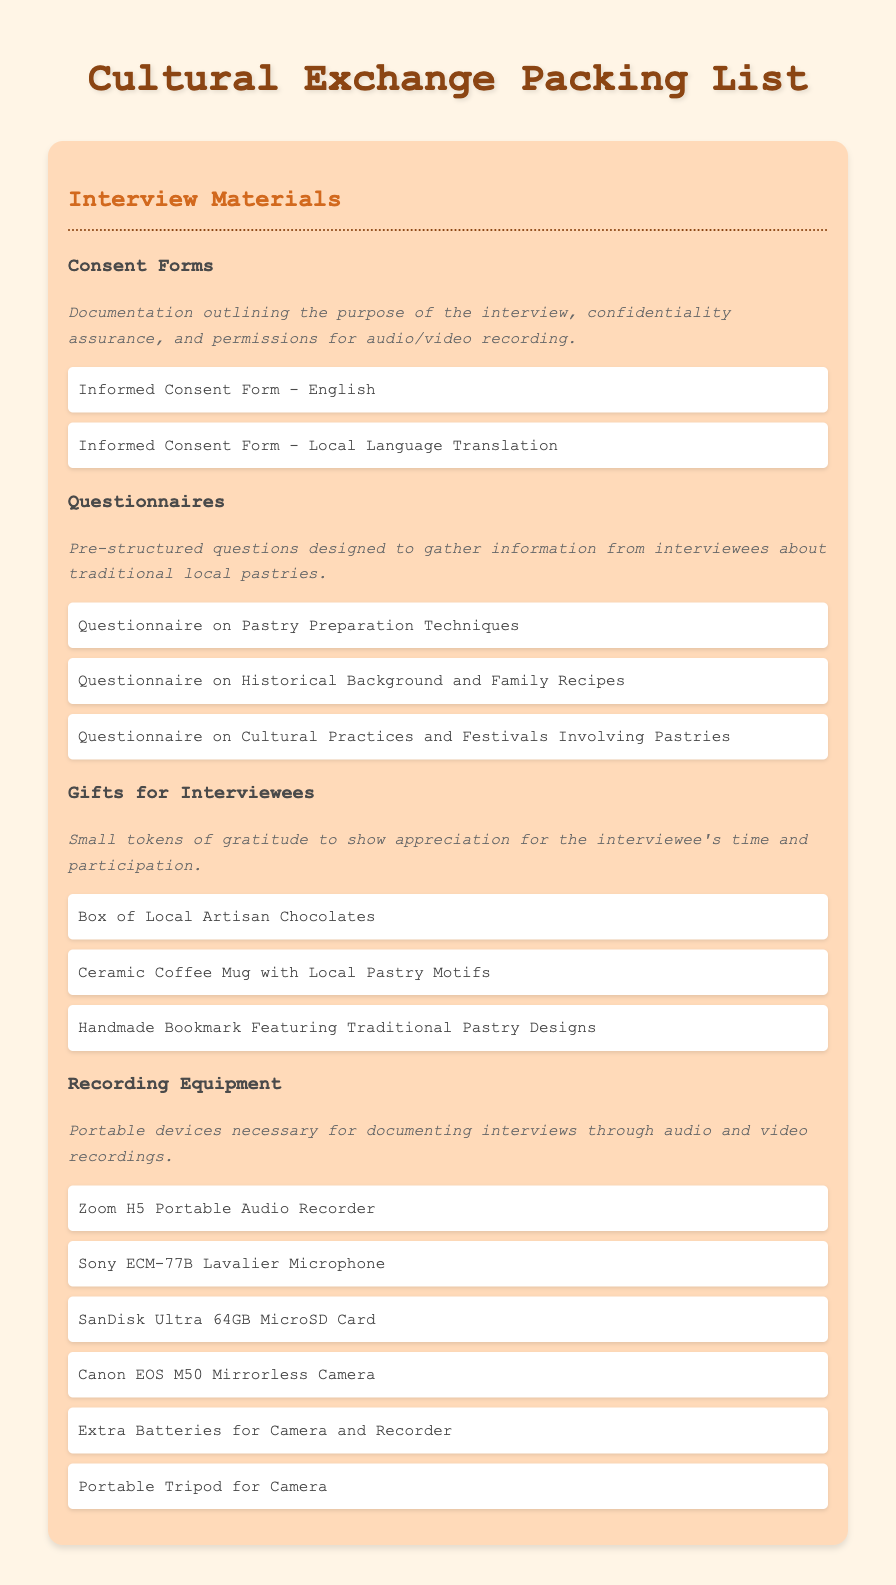what are the two languages for the consent forms? The document specifies that there is an Informed Consent Form in English and a Local Language Translation.
Answer: English, Local Language Translation how many questionnaires are listed? The document contains three specific questionnaires related to traditional local pastries.
Answer: Three what is one type of gift mentioned for interviewees? The document lists gifts like a Box of Local Artisan Chocolates as a token of gratitude.
Answer: Box of Local Artisan Chocolates what recording device is recommended for audio? The document mentions the Zoom H5 Portable Audio Recorder specifically for audio recording.
Answer: Zoom H5 Portable Audio Recorder what is the purpose of the questionnaires? The document indicates that the questionnaires are designed to gather information from interviewees about traditional local pastries.
Answer: Gather information about traditional local pastries how many recording equipment items are listed? There are six items specified under the recording equipment section in the document.
Answer: Six 